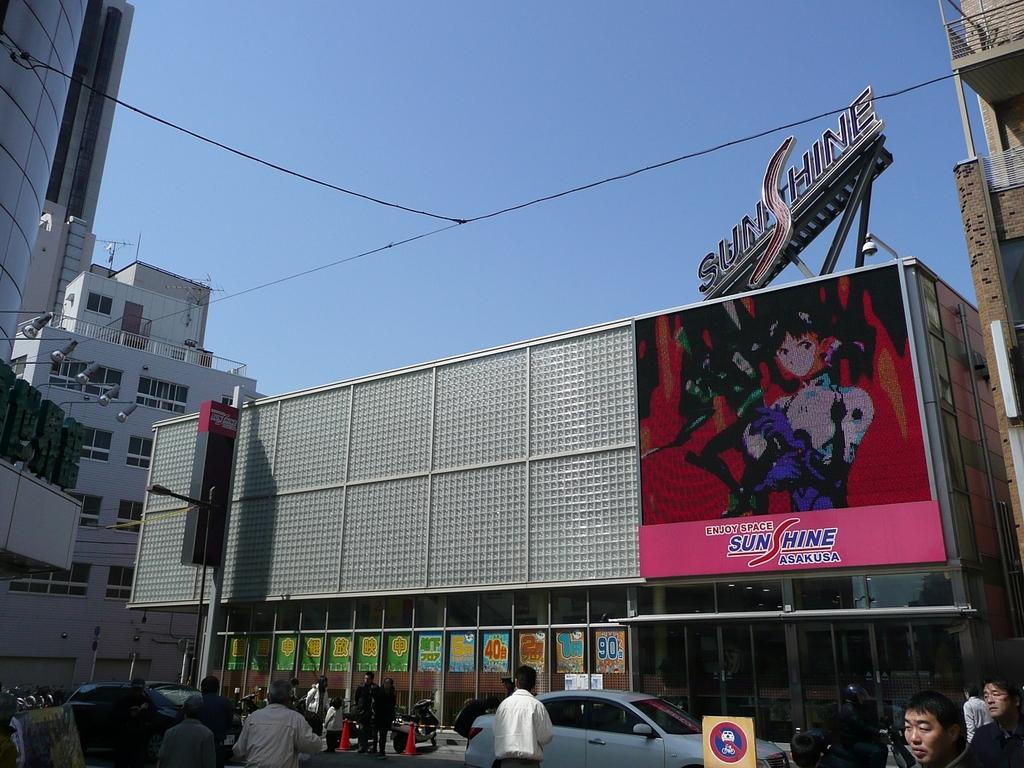<image>
Share a concise interpretation of the image provided. An Ad for SunShine Asakusa is prominently displayed on a building 